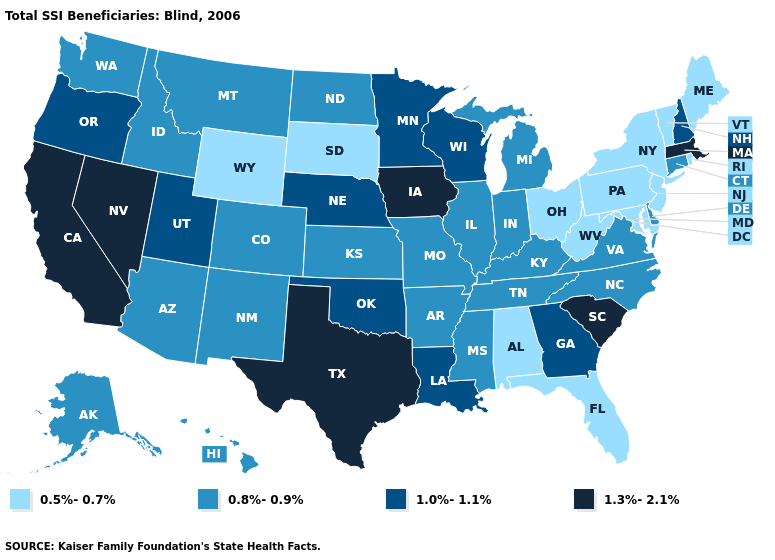What is the value of Alabama?
Give a very brief answer. 0.5%-0.7%. Among the states that border New Hampshire , which have the highest value?
Keep it brief. Massachusetts. Name the states that have a value in the range 0.5%-0.7%?
Be succinct. Alabama, Florida, Maine, Maryland, New Jersey, New York, Ohio, Pennsylvania, Rhode Island, South Dakota, Vermont, West Virginia, Wyoming. Does Massachusetts have the lowest value in the Northeast?
Short answer required. No. Name the states that have a value in the range 0.8%-0.9%?
Quick response, please. Alaska, Arizona, Arkansas, Colorado, Connecticut, Delaware, Hawaii, Idaho, Illinois, Indiana, Kansas, Kentucky, Michigan, Mississippi, Missouri, Montana, New Mexico, North Carolina, North Dakota, Tennessee, Virginia, Washington. What is the highest value in states that border Montana?
Write a very short answer. 0.8%-0.9%. Does the map have missing data?
Short answer required. No. What is the value of Florida?
Keep it brief. 0.5%-0.7%. How many symbols are there in the legend?
Write a very short answer. 4. What is the value of Michigan?
Short answer required. 0.8%-0.9%. Does the map have missing data?
Concise answer only. No. Which states have the highest value in the USA?
Quick response, please. California, Iowa, Massachusetts, Nevada, South Carolina, Texas. What is the lowest value in the Northeast?
Concise answer only. 0.5%-0.7%. Name the states that have a value in the range 0.8%-0.9%?
Write a very short answer. Alaska, Arizona, Arkansas, Colorado, Connecticut, Delaware, Hawaii, Idaho, Illinois, Indiana, Kansas, Kentucky, Michigan, Mississippi, Missouri, Montana, New Mexico, North Carolina, North Dakota, Tennessee, Virginia, Washington. Name the states that have a value in the range 1.3%-2.1%?
Keep it brief. California, Iowa, Massachusetts, Nevada, South Carolina, Texas. 